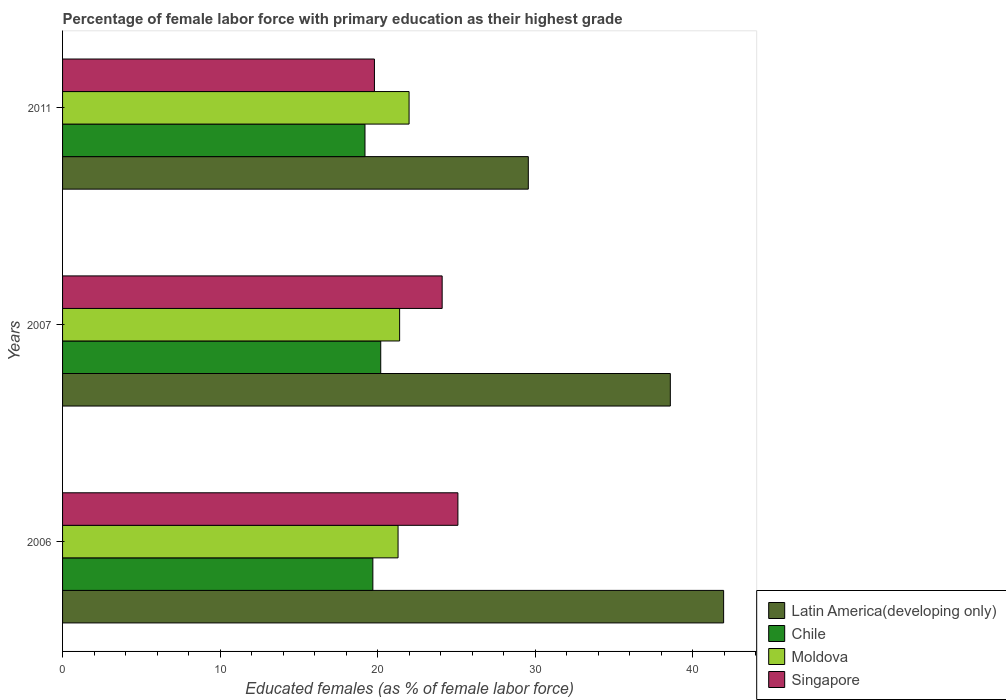How many different coloured bars are there?
Your answer should be compact. 4. Are the number of bars per tick equal to the number of legend labels?
Offer a very short reply. Yes. How many bars are there on the 1st tick from the top?
Offer a very short reply. 4. What is the label of the 2nd group of bars from the top?
Make the answer very short. 2007. In how many cases, is the number of bars for a given year not equal to the number of legend labels?
Your response must be concise. 0. What is the percentage of female labor force with primary education in Chile in 2006?
Your answer should be very brief. 19.7. Across all years, what is the minimum percentage of female labor force with primary education in Chile?
Your answer should be compact. 19.2. What is the total percentage of female labor force with primary education in Moldova in the graph?
Provide a short and direct response. 64.7. What is the difference between the percentage of female labor force with primary education in Singapore in 2006 and that in 2011?
Ensure brevity in your answer.  5.3. What is the difference between the percentage of female labor force with primary education in Latin America(developing only) in 2011 and the percentage of female labor force with primary education in Moldova in 2007?
Keep it short and to the point. 8.17. What is the average percentage of female labor force with primary education in Latin America(developing only) per year?
Your answer should be very brief. 36.71. In the year 2007, what is the difference between the percentage of female labor force with primary education in Latin America(developing only) and percentage of female labor force with primary education in Chile?
Provide a short and direct response. 18.39. What is the ratio of the percentage of female labor force with primary education in Latin America(developing only) in 2007 to that in 2011?
Provide a short and direct response. 1.3. What is the difference between the highest and the second highest percentage of female labor force with primary education in Latin America(developing only)?
Keep it short and to the point. 3.38. What is the difference between the highest and the lowest percentage of female labor force with primary education in Moldova?
Keep it short and to the point. 0.7. In how many years, is the percentage of female labor force with primary education in Moldova greater than the average percentage of female labor force with primary education in Moldova taken over all years?
Provide a short and direct response. 1. Is the sum of the percentage of female labor force with primary education in Latin America(developing only) in 2006 and 2007 greater than the maximum percentage of female labor force with primary education in Moldova across all years?
Your answer should be very brief. Yes. What does the 1st bar from the top in 2006 represents?
Provide a succinct answer. Singapore. Is it the case that in every year, the sum of the percentage of female labor force with primary education in Latin America(developing only) and percentage of female labor force with primary education in Moldova is greater than the percentage of female labor force with primary education in Chile?
Your answer should be compact. Yes. How many bars are there?
Ensure brevity in your answer.  12. How many years are there in the graph?
Your answer should be very brief. 3. Does the graph contain any zero values?
Your response must be concise. No. Does the graph contain grids?
Provide a short and direct response. No. Where does the legend appear in the graph?
Keep it short and to the point. Bottom right. How many legend labels are there?
Provide a succinct answer. 4. What is the title of the graph?
Your answer should be compact. Percentage of female labor force with primary education as their highest grade. What is the label or title of the X-axis?
Ensure brevity in your answer.  Educated females (as % of female labor force). What is the Educated females (as % of female labor force) in Latin America(developing only) in 2006?
Your answer should be compact. 41.97. What is the Educated females (as % of female labor force) of Chile in 2006?
Offer a very short reply. 19.7. What is the Educated females (as % of female labor force) of Moldova in 2006?
Provide a succinct answer. 21.3. What is the Educated females (as % of female labor force) in Singapore in 2006?
Keep it short and to the point. 25.1. What is the Educated females (as % of female labor force) in Latin America(developing only) in 2007?
Your response must be concise. 38.59. What is the Educated females (as % of female labor force) of Chile in 2007?
Ensure brevity in your answer.  20.2. What is the Educated females (as % of female labor force) in Moldova in 2007?
Your response must be concise. 21.4. What is the Educated females (as % of female labor force) in Singapore in 2007?
Your answer should be compact. 24.1. What is the Educated females (as % of female labor force) in Latin America(developing only) in 2011?
Ensure brevity in your answer.  29.57. What is the Educated females (as % of female labor force) of Chile in 2011?
Keep it short and to the point. 19.2. What is the Educated females (as % of female labor force) of Moldova in 2011?
Provide a succinct answer. 22. What is the Educated females (as % of female labor force) in Singapore in 2011?
Provide a succinct answer. 19.8. Across all years, what is the maximum Educated females (as % of female labor force) of Latin America(developing only)?
Offer a terse response. 41.97. Across all years, what is the maximum Educated females (as % of female labor force) in Chile?
Your answer should be very brief. 20.2. Across all years, what is the maximum Educated females (as % of female labor force) in Singapore?
Offer a terse response. 25.1. Across all years, what is the minimum Educated females (as % of female labor force) of Latin America(developing only)?
Ensure brevity in your answer.  29.57. Across all years, what is the minimum Educated females (as % of female labor force) in Chile?
Your response must be concise. 19.2. Across all years, what is the minimum Educated females (as % of female labor force) of Moldova?
Provide a short and direct response. 21.3. Across all years, what is the minimum Educated females (as % of female labor force) of Singapore?
Provide a succinct answer. 19.8. What is the total Educated females (as % of female labor force) of Latin America(developing only) in the graph?
Offer a very short reply. 110.13. What is the total Educated females (as % of female labor force) in Chile in the graph?
Offer a terse response. 59.1. What is the total Educated females (as % of female labor force) of Moldova in the graph?
Offer a terse response. 64.7. What is the difference between the Educated females (as % of female labor force) of Latin America(developing only) in 2006 and that in 2007?
Keep it short and to the point. 3.38. What is the difference between the Educated females (as % of female labor force) in Chile in 2006 and that in 2007?
Your response must be concise. -0.5. What is the difference between the Educated females (as % of female labor force) of Moldova in 2006 and that in 2007?
Offer a very short reply. -0.1. What is the difference between the Educated females (as % of female labor force) of Latin America(developing only) in 2006 and that in 2011?
Provide a succinct answer. 12.4. What is the difference between the Educated females (as % of female labor force) of Chile in 2006 and that in 2011?
Offer a terse response. 0.5. What is the difference between the Educated females (as % of female labor force) of Latin America(developing only) in 2007 and that in 2011?
Make the answer very short. 9.02. What is the difference between the Educated females (as % of female labor force) of Chile in 2007 and that in 2011?
Provide a short and direct response. 1. What is the difference between the Educated females (as % of female labor force) in Singapore in 2007 and that in 2011?
Provide a short and direct response. 4.3. What is the difference between the Educated females (as % of female labor force) in Latin America(developing only) in 2006 and the Educated females (as % of female labor force) in Chile in 2007?
Keep it short and to the point. 21.77. What is the difference between the Educated females (as % of female labor force) in Latin America(developing only) in 2006 and the Educated females (as % of female labor force) in Moldova in 2007?
Provide a succinct answer. 20.57. What is the difference between the Educated females (as % of female labor force) of Latin America(developing only) in 2006 and the Educated females (as % of female labor force) of Singapore in 2007?
Make the answer very short. 17.87. What is the difference between the Educated females (as % of female labor force) in Chile in 2006 and the Educated females (as % of female labor force) in Moldova in 2007?
Your response must be concise. -1.7. What is the difference between the Educated females (as % of female labor force) of Moldova in 2006 and the Educated females (as % of female labor force) of Singapore in 2007?
Ensure brevity in your answer.  -2.8. What is the difference between the Educated females (as % of female labor force) in Latin America(developing only) in 2006 and the Educated females (as % of female labor force) in Chile in 2011?
Your answer should be compact. 22.77. What is the difference between the Educated females (as % of female labor force) of Latin America(developing only) in 2006 and the Educated females (as % of female labor force) of Moldova in 2011?
Your answer should be very brief. 19.97. What is the difference between the Educated females (as % of female labor force) in Latin America(developing only) in 2006 and the Educated females (as % of female labor force) in Singapore in 2011?
Your answer should be very brief. 22.17. What is the difference between the Educated females (as % of female labor force) in Chile in 2006 and the Educated females (as % of female labor force) in Moldova in 2011?
Make the answer very short. -2.3. What is the difference between the Educated females (as % of female labor force) in Moldova in 2006 and the Educated females (as % of female labor force) in Singapore in 2011?
Make the answer very short. 1.5. What is the difference between the Educated females (as % of female labor force) of Latin America(developing only) in 2007 and the Educated females (as % of female labor force) of Chile in 2011?
Provide a succinct answer. 19.39. What is the difference between the Educated females (as % of female labor force) in Latin America(developing only) in 2007 and the Educated females (as % of female labor force) in Moldova in 2011?
Offer a terse response. 16.59. What is the difference between the Educated females (as % of female labor force) in Latin America(developing only) in 2007 and the Educated females (as % of female labor force) in Singapore in 2011?
Your response must be concise. 18.79. What is the difference between the Educated females (as % of female labor force) in Chile in 2007 and the Educated females (as % of female labor force) in Moldova in 2011?
Give a very brief answer. -1.8. What is the difference between the Educated females (as % of female labor force) of Moldova in 2007 and the Educated females (as % of female labor force) of Singapore in 2011?
Provide a succinct answer. 1.6. What is the average Educated females (as % of female labor force) of Latin America(developing only) per year?
Keep it short and to the point. 36.71. What is the average Educated females (as % of female labor force) in Chile per year?
Offer a very short reply. 19.7. What is the average Educated females (as % of female labor force) in Moldova per year?
Your answer should be compact. 21.57. What is the average Educated females (as % of female labor force) in Singapore per year?
Provide a succinct answer. 23. In the year 2006, what is the difference between the Educated females (as % of female labor force) in Latin America(developing only) and Educated females (as % of female labor force) in Chile?
Offer a very short reply. 22.27. In the year 2006, what is the difference between the Educated females (as % of female labor force) of Latin America(developing only) and Educated females (as % of female labor force) of Moldova?
Your answer should be very brief. 20.67. In the year 2006, what is the difference between the Educated females (as % of female labor force) of Latin America(developing only) and Educated females (as % of female labor force) of Singapore?
Give a very brief answer. 16.87. In the year 2006, what is the difference between the Educated females (as % of female labor force) in Moldova and Educated females (as % of female labor force) in Singapore?
Your answer should be very brief. -3.8. In the year 2007, what is the difference between the Educated females (as % of female labor force) in Latin America(developing only) and Educated females (as % of female labor force) in Chile?
Keep it short and to the point. 18.39. In the year 2007, what is the difference between the Educated females (as % of female labor force) of Latin America(developing only) and Educated females (as % of female labor force) of Moldova?
Ensure brevity in your answer.  17.19. In the year 2007, what is the difference between the Educated females (as % of female labor force) of Latin America(developing only) and Educated females (as % of female labor force) of Singapore?
Offer a very short reply. 14.49. In the year 2007, what is the difference between the Educated females (as % of female labor force) in Chile and Educated females (as % of female labor force) in Moldova?
Your response must be concise. -1.2. In the year 2011, what is the difference between the Educated females (as % of female labor force) in Latin America(developing only) and Educated females (as % of female labor force) in Chile?
Your answer should be compact. 10.37. In the year 2011, what is the difference between the Educated females (as % of female labor force) in Latin America(developing only) and Educated females (as % of female labor force) in Moldova?
Keep it short and to the point. 7.57. In the year 2011, what is the difference between the Educated females (as % of female labor force) of Latin America(developing only) and Educated females (as % of female labor force) of Singapore?
Your response must be concise. 9.77. What is the ratio of the Educated females (as % of female labor force) of Latin America(developing only) in 2006 to that in 2007?
Your response must be concise. 1.09. What is the ratio of the Educated females (as % of female labor force) of Chile in 2006 to that in 2007?
Provide a short and direct response. 0.98. What is the ratio of the Educated females (as % of female labor force) of Moldova in 2006 to that in 2007?
Your answer should be compact. 1. What is the ratio of the Educated females (as % of female labor force) of Singapore in 2006 to that in 2007?
Ensure brevity in your answer.  1.04. What is the ratio of the Educated females (as % of female labor force) in Latin America(developing only) in 2006 to that in 2011?
Offer a terse response. 1.42. What is the ratio of the Educated females (as % of female labor force) of Chile in 2006 to that in 2011?
Make the answer very short. 1.03. What is the ratio of the Educated females (as % of female labor force) in Moldova in 2006 to that in 2011?
Offer a very short reply. 0.97. What is the ratio of the Educated females (as % of female labor force) of Singapore in 2006 to that in 2011?
Keep it short and to the point. 1.27. What is the ratio of the Educated females (as % of female labor force) in Latin America(developing only) in 2007 to that in 2011?
Provide a short and direct response. 1.3. What is the ratio of the Educated females (as % of female labor force) in Chile in 2007 to that in 2011?
Make the answer very short. 1.05. What is the ratio of the Educated females (as % of female labor force) of Moldova in 2007 to that in 2011?
Offer a terse response. 0.97. What is the ratio of the Educated females (as % of female labor force) in Singapore in 2007 to that in 2011?
Provide a succinct answer. 1.22. What is the difference between the highest and the second highest Educated females (as % of female labor force) in Latin America(developing only)?
Your answer should be compact. 3.38. What is the difference between the highest and the second highest Educated females (as % of female labor force) of Chile?
Your answer should be compact. 0.5. What is the difference between the highest and the second highest Educated females (as % of female labor force) of Singapore?
Your answer should be very brief. 1. What is the difference between the highest and the lowest Educated females (as % of female labor force) of Latin America(developing only)?
Your response must be concise. 12.4. What is the difference between the highest and the lowest Educated females (as % of female labor force) of Chile?
Make the answer very short. 1. What is the difference between the highest and the lowest Educated females (as % of female labor force) in Moldova?
Keep it short and to the point. 0.7. What is the difference between the highest and the lowest Educated females (as % of female labor force) of Singapore?
Provide a short and direct response. 5.3. 